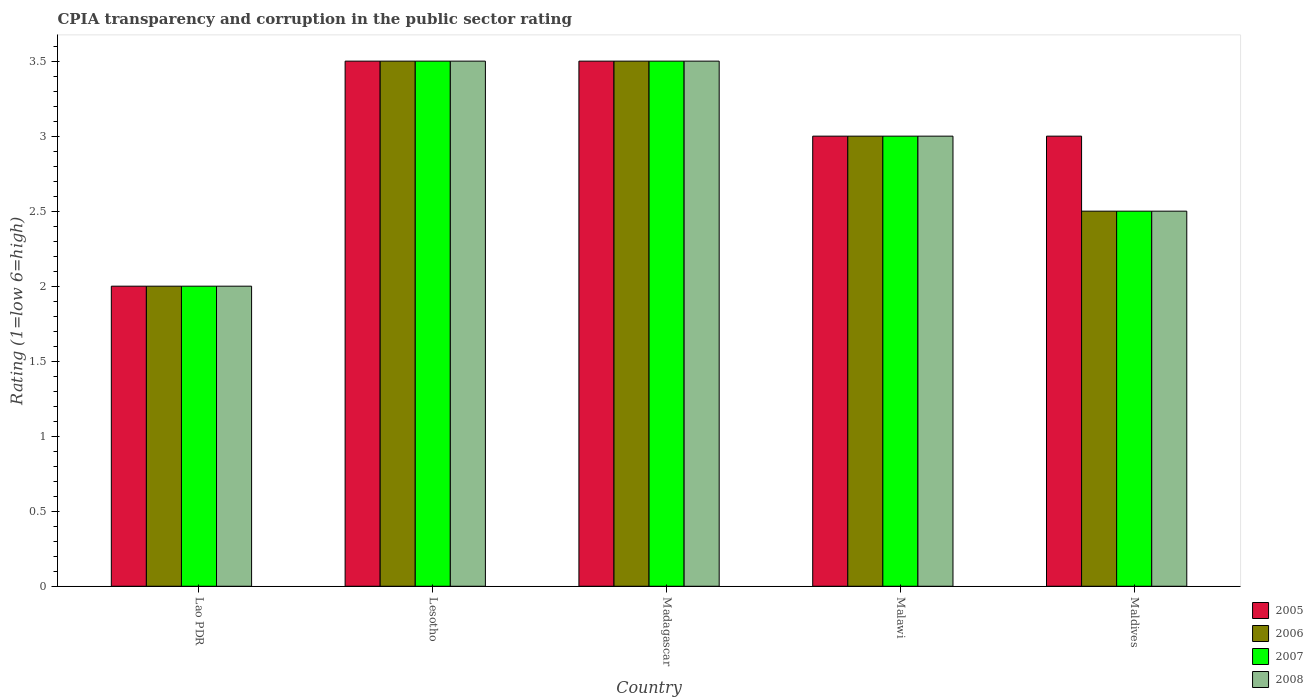How many different coloured bars are there?
Provide a short and direct response. 4. How many groups of bars are there?
Keep it short and to the point. 5. Are the number of bars per tick equal to the number of legend labels?
Your answer should be compact. Yes. How many bars are there on the 1st tick from the left?
Offer a very short reply. 4. How many bars are there on the 5th tick from the right?
Give a very brief answer. 4. What is the label of the 2nd group of bars from the left?
Ensure brevity in your answer.  Lesotho. What is the CPIA rating in 2005 in Madagascar?
Provide a succinct answer. 3.5. Across all countries, what is the maximum CPIA rating in 2006?
Keep it short and to the point. 3.5. Across all countries, what is the minimum CPIA rating in 2005?
Your answer should be very brief. 2. In which country was the CPIA rating in 2005 maximum?
Your response must be concise. Lesotho. In which country was the CPIA rating in 2007 minimum?
Provide a succinct answer. Lao PDR. In how many countries, is the CPIA rating in 2005 greater than 1.4?
Your answer should be compact. 5. What is the ratio of the CPIA rating in 2005 in Lao PDR to that in Lesotho?
Provide a short and direct response. 0.57. Is the CPIA rating in 2008 in Lao PDR less than that in Malawi?
Your response must be concise. Yes. Is the difference between the CPIA rating in 2005 in Lao PDR and Maldives greater than the difference between the CPIA rating in 2008 in Lao PDR and Maldives?
Offer a very short reply. No. What is the difference between the highest and the second highest CPIA rating in 2005?
Give a very brief answer. -0.5. What is the difference between the highest and the lowest CPIA rating in 2008?
Give a very brief answer. 1.5. In how many countries, is the CPIA rating in 2007 greater than the average CPIA rating in 2007 taken over all countries?
Keep it short and to the point. 3. Is the sum of the CPIA rating in 2006 in Lao PDR and Lesotho greater than the maximum CPIA rating in 2007 across all countries?
Offer a terse response. Yes. Is it the case that in every country, the sum of the CPIA rating in 2008 and CPIA rating in 2005 is greater than the sum of CPIA rating in 2007 and CPIA rating in 2006?
Your answer should be compact. No. What does the 2nd bar from the left in Madagascar represents?
Provide a short and direct response. 2006. What does the 1st bar from the right in Maldives represents?
Make the answer very short. 2008. Is it the case that in every country, the sum of the CPIA rating in 2008 and CPIA rating in 2007 is greater than the CPIA rating in 2005?
Give a very brief answer. Yes. How many bars are there?
Your answer should be very brief. 20. Are all the bars in the graph horizontal?
Your response must be concise. No. How many countries are there in the graph?
Make the answer very short. 5. Are the values on the major ticks of Y-axis written in scientific E-notation?
Offer a terse response. No. How many legend labels are there?
Offer a terse response. 4. How are the legend labels stacked?
Provide a succinct answer. Vertical. What is the title of the graph?
Your response must be concise. CPIA transparency and corruption in the public sector rating. What is the Rating (1=low 6=high) of 2005 in Lao PDR?
Offer a terse response. 2. What is the Rating (1=low 6=high) in 2006 in Lao PDR?
Keep it short and to the point. 2. What is the Rating (1=low 6=high) in 2008 in Lao PDR?
Your response must be concise. 2. What is the Rating (1=low 6=high) in 2008 in Lesotho?
Offer a very short reply. 3.5. What is the Rating (1=low 6=high) in 2005 in Madagascar?
Your answer should be very brief. 3.5. What is the Rating (1=low 6=high) in 2006 in Madagascar?
Ensure brevity in your answer.  3.5. What is the Rating (1=low 6=high) of 2008 in Madagascar?
Ensure brevity in your answer.  3.5. What is the Rating (1=low 6=high) in 2008 in Malawi?
Your response must be concise. 3. Across all countries, what is the maximum Rating (1=low 6=high) in 2005?
Make the answer very short. 3.5. Across all countries, what is the maximum Rating (1=low 6=high) in 2007?
Offer a very short reply. 3.5. Across all countries, what is the minimum Rating (1=low 6=high) of 2005?
Provide a short and direct response. 2. What is the total Rating (1=low 6=high) of 2006 in the graph?
Provide a succinct answer. 14.5. What is the difference between the Rating (1=low 6=high) of 2007 in Lao PDR and that in Lesotho?
Offer a very short reply. -1.5. What is the difference between the Rating (1=low 6=high) of 2005 in Lao PDR and that in Madagascar?
Offer a terse response. -1.5. What is the difference between the Rating (1=low 6=high) in 2008 in Lao PDR and that in Madagascar?
Ensure brevity in your answer.  -1.5. What is the difference between the Rating (1=low 6=high) in 2005 in Lao PDR and that in Malawi?
Offer a terse response. -1. What is the difference between the Rating (1=low 6=high) of 2007 in Lao PDR and that in Malawi?
Your answer should be compact. -1. What is the difference between the Rating (1=low 6=high) of 2006 in Lesotho and that in Madagascar?
Provide a succinct answer. 0. What is the difference between the Rating (1=low 6=high) of 2008 in Lesotho and that in Madagascar?
Provide a short and direct response. 0. What is the difference between the Rating (1=low 6=high) of 2006 in Lesotho and that in Malawi?
Provide a short and direct response. 0.5. What is the difference between the Rating (1=low 6=high) in 2008 in Lesotho and that in Malawi?
Your answer should be very brief. 0.5. What is the difference between the Rating (1=low 6=high) of 2008 in Lesotho and that in Maldives?
Provide a succinct answer. 1. What is the difference between the Rating (1=low 6=high) in 2005 in Madagascar and that in Malawi?
Make the answer very short. 0.5. What is the difference between the Rating (1=low 6=high) in 2008 in Madagascar and that in Malawi?
Keep it short and to the point. 0.5. What is the difference between the Rating (1=low 6=high) of 2006 in Madagascar and that in Maldives?
Your answer should be very brief. 1. What is the difference between the Rating (1=low 6=high) of 2008 in Madagascar and that in Maldives?
Keep it short and to the point. 1. What is the difference between the Rating (1=low 6=high) of 2008 in Malawi and that in Maldives?
Provide a succinct answer. 0.5. What is the difference between the Rating (1=low 6=high) in 2005 in Lao PDR and the Rating (1=low 6=high) in 2007 in Lesotho?
Offer a terse response. -1.5. What is the difference between the Rating (1=low 6=high) of 2005 in Lao PDR and the Rating (1=low 6=high) of 2006 in Madagascar?
Give a very brief answer. -1.5. What is the difference between the Rating (1=low 6=high) in 2005 in Lao PDR and the Rating (1=low 6=high) in 2007 in Madagascar?
Keep it short and to the point. -1.5. What is the difference between the Rating (1=low 6=high) of 2005 in Lao PDR and the Rating (1=low 6=high) of 2008 in Madagascar?
Give a very brief answer. -1.5. What is the difference between the Rating (1=low 6=high) of 2006 in Lao PDR and the Rating (1=low 6=high) of 2007 in Malawi?
Make the answer very short. -1. What is the difference between the Rating (1=low 6=high) of 2006 in Lao PDR and the Rating (1=low 6=high) of 2008 in Malawi?
Ensure brevity in your answer.  -1. What is the difference between the Rating (1=low 6=high) in 2005 in Lao PDR and the Rating (1=low 6=high) in 2006 in Maldives?
Your answer should be compact. -0.5. What is the difference between the Rating (1=low 6=high) of 2005 in Lao PDR and the Rating (1=low 6=high) of 2007 in Maldives?
Offer a very short reply. -0.5. What is the difference between the Rating (1=low 6=high) of 2006 in Lao PDR and the Rating (1=low 6=high) of 2008 in Maldives?
Your answer should be compact. -0.5. What is the difference between the Rating (1=low 6=high) of 2005 in Lesotho and the Rating (1=low 6=high) of 2008 in Madagascar?
Ensure brevity in your answer.  0. What is the difference between the Rating (1=low 6=high) in 2006 in Lesotho and the Rating (1=low 6=high) in 2007 in Madagascar?
Offer a terse response. 0. What is the difference between the Rating (1=low 6=high) in 2006 in Lesotho and the Rating (1=low 6=high) in 2008 in Madagascar?
Give a very brief answer. 0. What is the difference between the Rating (1=low 6=high) of 2007 in Lesotho and the Rating (1=low 6=high) of 2008 in Madagascar?
Ensure brevity in your answer.  0. What is the difference between the Rating (1=low 6=high) of 2005 in Lesotho and the Rating (1=low 6=high) of 2006 in Malawi?
Offer a terse response. 0.5. What is the difference between the Rating (1=low 6=high) in 2006 in Lesotho and the Rating (1=low 6=high) in 2008 in Malawi?
Your answer should be very brief. 0.5. What is the difference between the Rating (1=low 6=high) of 2007 in Lesotho and the Rating (1=low 6=high) of 2008 in Malawi?
Your answer should be compact. 0.5. What is the difference between the Rating (1=low 6=high) of 2005 in Lesotho and the Rating (1=low 6=high) of 2007 in Maldives?
Offer a very short reply. 1. What is the difference between the Rating (1=low 6=high) of 2006 in Lesotho and the Rating (1=low 6=high) of 2008 in Maldives?
Provide a succinct answer. 1. What is the difference between the Rating (1=low 6=high) in 2007 in Lesotho and the Rating (1=low 6=high) in 2008 in Maldives?
Make the answer very short. 1. What is the difference between the Rating (1=low 6=high) in 2005 in Madagascar and the Rating (1=low 6=high) in 2008 in Malawi?
Provide a short and direct response. 0.5. What is the difference between the Rating (1=low 6=high) in 2006 in Madagascar and the Rating (1=low 6=high) in 2007 in Malawi?
Make the answer very short. 0.5. What is the difference between the Rating (1=low 6=high) of 2005 in Madagascar and the Rating (1=low 6=high) of 2006 in Maldives?
Offer a terse response. 1. What is the difference between the Rating (1=low 6=high) in 2005 in Madagascar and the Rating (1=low 6=high) in 2008 in Maldives?
Your response must be concise. 1. What is the difference between the Rating (1=low 6=high) in 2006 in Madagascar and the Rating (1=low 6=high) in 2008 in Maldives?
Ensure brevity in your answer.  1. What is the difference between the Rating (1=low 6=high) of 2005 in Malawi and the Rating (1=low 6=high) of 2007 in Maldives?
Offer a very short reply. 0.5. What is the difference between the Rating (1=low 6=high) of 2005 in Malawi and the Rating (1=low 6=high) of 2008 in Maldives?
Your answer should be very brief. 0.5. What is the difference between the Rating (1=low 6=high) in 2006 in Malawi and the Rating (1=low 6=high) in 2008 in Maldives?
Offer a terse response. 0.5. What is the difference between the Rating (1=low 6=high) of 2007 in Malawi and the Rating (1=low 6=high) of 2008 in Maldives?
Make the answer very short. 0.5. What is the average Rating (1=low 6=high) in 2007 per country?
Offer a terse response. 2.9. What is the average Rating (1=low 6=high) in 2008 per country?
Offer a terse response. 2.9. What is the difference between the Rating (1=low 6=high) in 2005 and Rating (1=low 6=high) in 2006 in Lao PDR?
Ensure brevity in your answer.  0. What is the difference between the Rating (1=low 6=high) of 2005 and Rating (1=low 6=high) of 2008 in Lao PDR?
Provide a succinct answer. 0. What is the difference between the Rating (1=low 6=high) of 2006 and Rating (1=low 6=high) of 2007 in Lao PDR?
Offer a terse response. 0. What is the difference between the Rating (1=low 6=high) of 2007 and Rating (1=low 6=high) of 2008 in Lao PDR?
Ensure brevity in your answer.  0. What is the difference between the Rating (1=low 6=high) in 2005 and Rating (1=low 6=high) in 2006 in Lesotho?
Provide a succinct answer. 0. What is the difference between the Rating (1=low 6=high) in 2005 and Rating (1=low 6=high) in 2007 in Lesotho?
Offer a very short reply. 0. What is the difference between the Rating (1=low 6=high) in 2006 and Rating (1=low 6=high) in 2007 in Lesotho?
Keep it short and to the point. 0. What is the difference between the Rating (1=low 6=high) of 2005 and Rating (1=low 6=high) of 2006 in Madagascar?
Give a very brief answer. 0. What is the difference between the Rating (1=low 6=high) of 2006 and Rating (1=low 6=high) of 2007 in Madagascar?
Ensure brevity in your answer.  0. What is the difference between the Rating (1=low 6=high) in 2006 and Rating (1=low 6=high) in 2008 in Madagascar?
Ensure brevity in your answer.  0. What is the difference between the Rating (1=low 6=high) in 2005 and Rating (1=low 6=high) in 2007 in Malawi?
Ensure brevity in your answer.  0. What is the difference between the Rating (1=low 6=high) of 2006 and Rating (1=low 6=high) of 2007 in Malawi?
Ensure brevity in your answer.  0. What is the difference between the Rating (1=low 6=high) of 2007 and Rating (1=low 6=high) of 2008 in Malawi?
Keep it short and to the point. 0. What is the difference between the Rating (1=low 6=high) of 2006 and Rating (1=low 6=high) of 2007 in Maldives?
Ensure brevity in your answer.  0. What is the difference between the Rating (1=low 6=high) of 2007 and Rating (1=low 6=high) of 2008 in Maldives?
Provide a succinct answer. 0. What is the ratio of the Rating (1=low 6=high) of 2008 in Lao PDR to that in Lesotho?
Your response must be concise. 0.57. What is the ratio of the Rating (1=low 6=high) of 2006 in Lao PDR to that in Madagascar?
Keep it short and to the point. 0.57. What is the ratio of the Rating (1=low 6=high) in 2007 in Lao PDR to that in Madagascar?
Keep it short and to the point. 0.57. What is the ratio of the Rating (1=low 6=high) in 2008 in Lao PDR to that in Madagascar?
Keep it short and to the point. 0.57. What is the ratio of the Rating (1=low 6=high) of 2005 in Lao PDR to that in Malawi?
Offer a very short reply. 0.67. What is the ratio of the Rating (1=low 6=high) of 2008 in Lao PDR to that in Malawi?
Provide a succinct answer. 0.67. What is the ratio of the Rating (1=low 6=high) of 2006 in Lao PDR to that in Maldives?
Your answer should be compact. 0.8. What is the ratio of the Rating (1=low 6=high) in 2006 in Lesotho to that in Madagascar?
Make the answer very short. 1. What is the ratio of the Rating (1=low 6=high) in 2007 in Lesotho to that in Madagascar?
Your answer should be very brief. 1. What is the ratio of the Rating (1=low 6=high) of 2005 in Lesotho to that in Malawi?
Offer a terse response. 1.17. What is the ratio of the Rating (1=low 6=high) in 2007 in Lesotho to that in Malawi?
Your answer should be compact. 1.17. What is the ratio of the Rating (1=low 6=high) of 2006 in Lesotho to that in Maldives?
Offer a terse response. 1.4. What is the ratio of the Rating (1=low 6=high) in 2007 in Lesotho to that in Maldives?
Provide a short and direct response. 1.4. What is the ratio of the Rating (1=low 6=high) of 2008 in Lesotho to that in Maldives?
Give a very brief answer. 1.4. What is the ratio of the Rating (1=low 6=high) of 2008 in Madagascar to that in Malawi?
Make the answer very short. 1.17. What is the ratio of the Rating (1=low 6=high) of 2005 in Madagascar to that in Maldives?
Keep it short and to the point. 1.17. What is the ratio of the Rating (1=low 6=high) of 2008 in Madagascar to that in Maldives?
Offer a terse response. 1.4. What is the ratio of the Rating (1=low 6=high) of 2006 in Malawi to that in Maldives?
Keep it short and to the point. 1.2. What is the ratio of the Rating (1=low 6=high) of 2007 in Malawi to that in Maldives?
Ensure brevity in your answer.  1.2. What is the difference between the highest and the second highest Rating (1=low 6=high) in 2005?
Your response must be concise. 0. What is the difference between the highest and the second highest Rating (1=low 6=high) in 2007?
Provide a succinct answer. 0. What is the difference between the highest and the lowest Rating (1=low 6=high) in 2005?
Give a very brief answer. 1.5. What is the difference between the highest and the lowest Rating (1=low 6=high) of 2007?
Provide a short and direct response. 1.5. What is the difference between the highest and the lowest Rating (1=low 6=high) of 2008?
Your answer should be very brief. 1.5. 